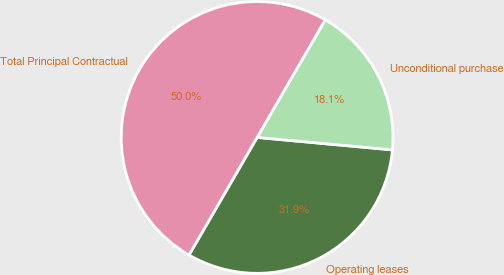<chart> <loc_0><loc_0><loc_500><loc_500><pie_chart><fcel>Operating leases<fcel>Unconditional purchase<fcel>Total Principal Contractual<nl><fcel>31.89%<fcel>18.11%<fcel>50.0%<nl></chart> 